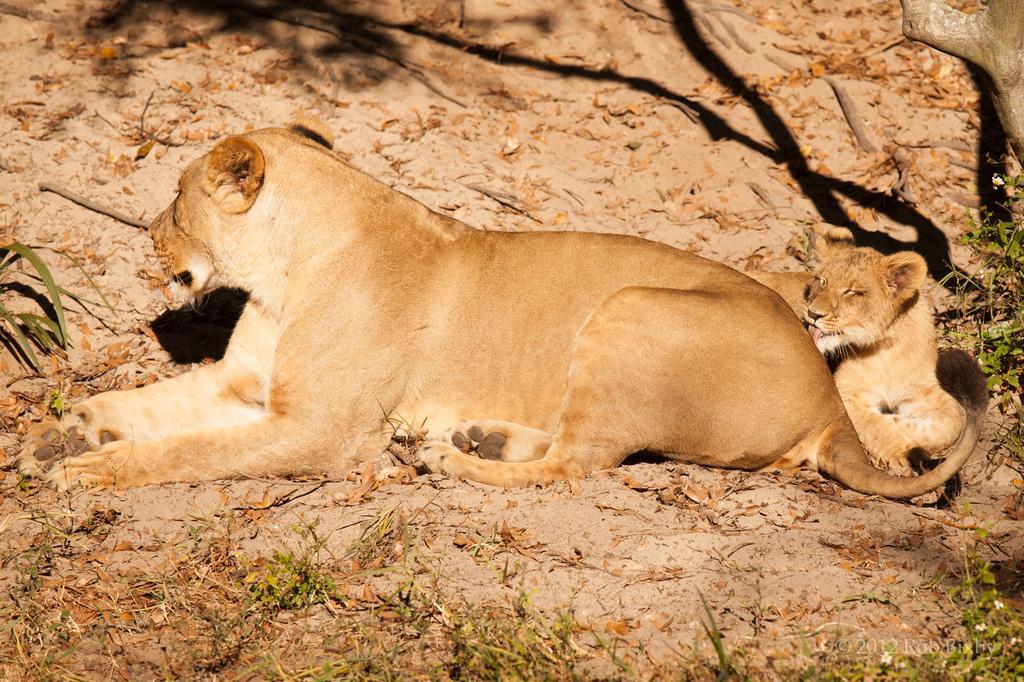Can you describe this image briefly? In this image we can see the animals, there are some plants and leaves on the ground, also we can see the trunk. 